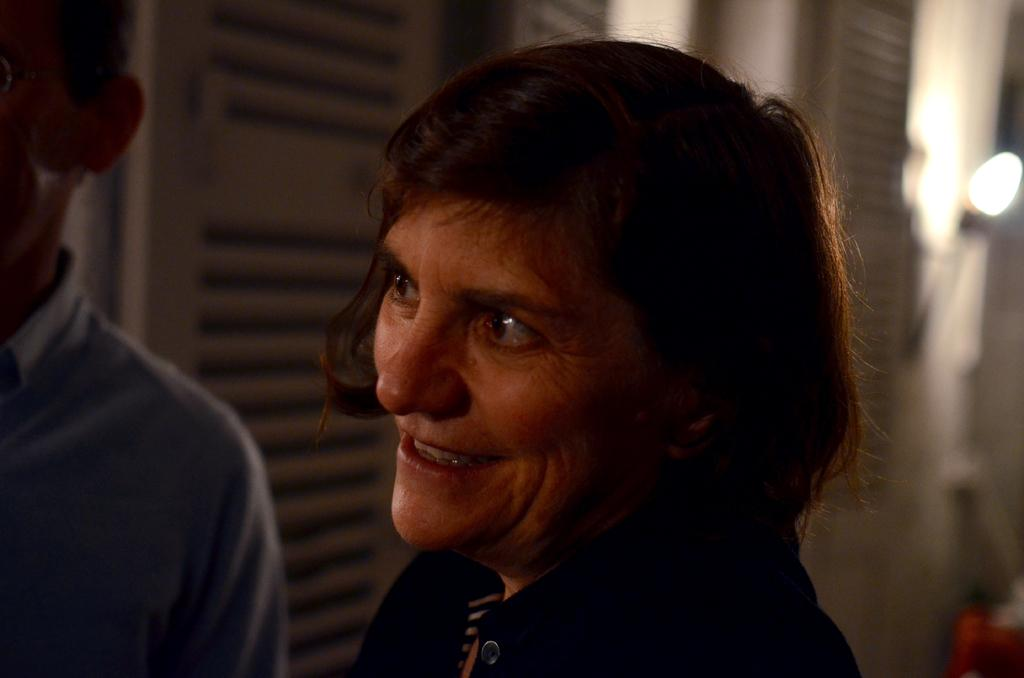Who is present in the image? There is a woman in the image. What is the woman doing in the image? The woman is smiling. Can you describe the other person in the image? There is another person standing on the left side of the image. What can be seen in the background of the image? There are doors visible in the background of the image. What type of quince is being served at the committee meeting in the image? There is no quince or committee meeting present in the image. What kind of wine is being poured for the woman in the image? There is no wine present in the image. 